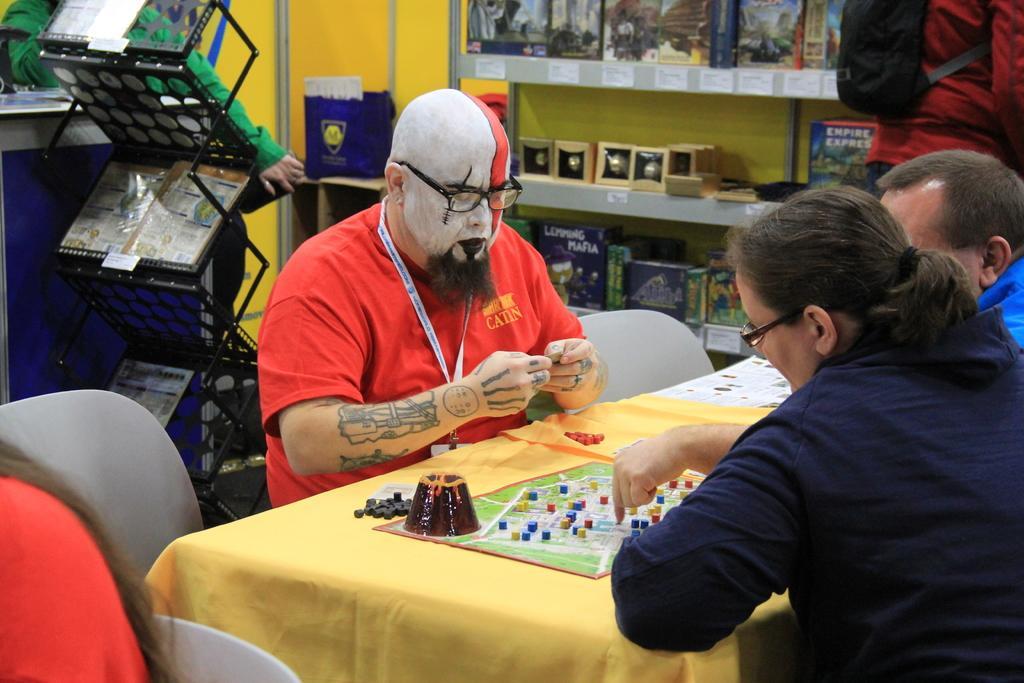Could you give a brief overview of what you see in this image? This is a picture taken in a room. The man in red t shirt was sitting on a chair and there are other people sitting on a chair. In front of this people there is a table on the table is some game. Behind the people there is a wall. 